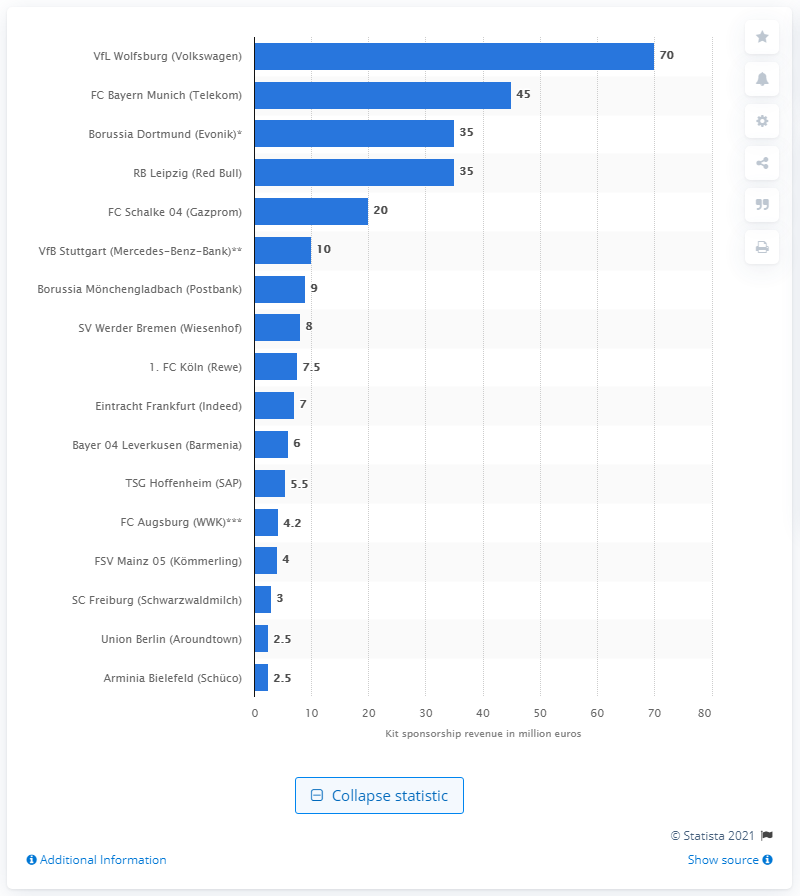Identify some key points in this picture. It has been announced that VfL Wolfsburg will receive a significant sum of money from its kit sponsor Volkswagen for the 2020/21 season, amounting to 70.. 